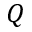<formula> <loc_0><loc_0><loc_500><loc_500>Q</formula> 